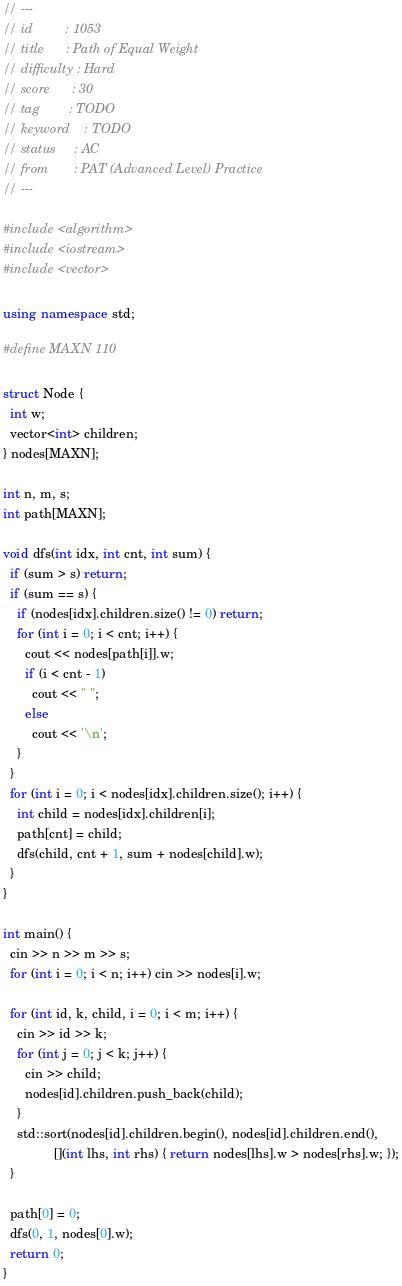Convert code to text. <code><loc_0><loc_0><loc_500><loc_500><_C++_>// ---
// id         : 1053
// title      : Path of Equal Weight
// difficulty : Hard
// score      : 30
// tag        : TODO
// keyword    : TODO
// status     : AC
// from       : PAT (Advanced Level) Practice
// ---

#include <algorithm>
#include <iostream>
#include <vector>

using namespace std;

#define MAXN 110

struct Node {
  int w;
  vector<int> children;
} nodes[MAXN];

int n, m, s;
int path[MAXN];

void dfs(int idx, int cnt, int sum) {
  if (sum > s) return;
  if (sum == s) {
    if (nodes[idx].children.size() != 0) return;
    for (int i = 0; i < cnt; i++) {
      cout << nodes[path[i]].w;
      if (i < cnt - 1)
        cout << " ";
      else
        cout << '\n';
    }
  }
  for (int i = 0; i < nodes[idx].children.size(); i++) {
    int child = nodes[idx].children[i];
    path[cnt] = child;
    dfs(child, cnt + 1, sum + nodes[child].w);
  }
}

int main() {
  cin >> n >> m >> s;
  for (int i = 0; i < n; i++) cin >> nodes[i].w;

  for (int id, k, child, i = 0; i < m; i++) {
    cin >> id >> k;
    for (int j = 0; j < k; j++) {
      cin >> child;
      nodes[id].children.push_back(child);
    }
    std::sort(nodes[id].children.begin(), nodes[id].children.end(),
              [](int lhs, int rhs) { return nodes[lhs].w > nodes[rhs].w; });
  }

  path[0] = 0;
  dfs(0, 1, nodes[0].w);
  return 0;
}</code> 